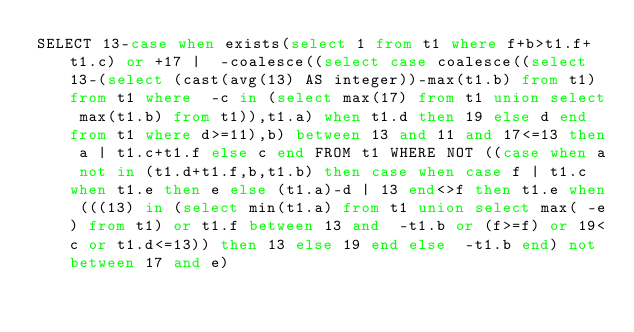<code> <loc_0><loc_0><loc_500><loc_500><_SQL_>SELECT 13-case when exists(select 1 from t1 where f+b>t1.f+t1.c) or +17 |  -coalesce((select case coalesce((select 13-(select (cast(avg(13) AS integer))-max(t1.b) from t1) from t1 where  -c in (select max(17) from t1 union select max(t1.b) from t1)),t1.a) when t1.d then 19 else d end from t1 where d>=11),b) between 13 and 11 and 17<=13 then a | t1.c+t1.f else c end FROM t1 WHERE NOT ((case when a not in (t1.d+t1.f,b,t1.b) then case when case f | t1.c when t1.e then e else (t1.a)-d | 13 end<>f then t1.e when (((13) in (select min(t1.a) from t1 union select max( -e) from t1) or t1.f between 13 and  -t1.b or (f>=f) or 19<c or t1.d<=13)) then 13 else 19 end else  -t1.b end) not between 17 and e)</code> 